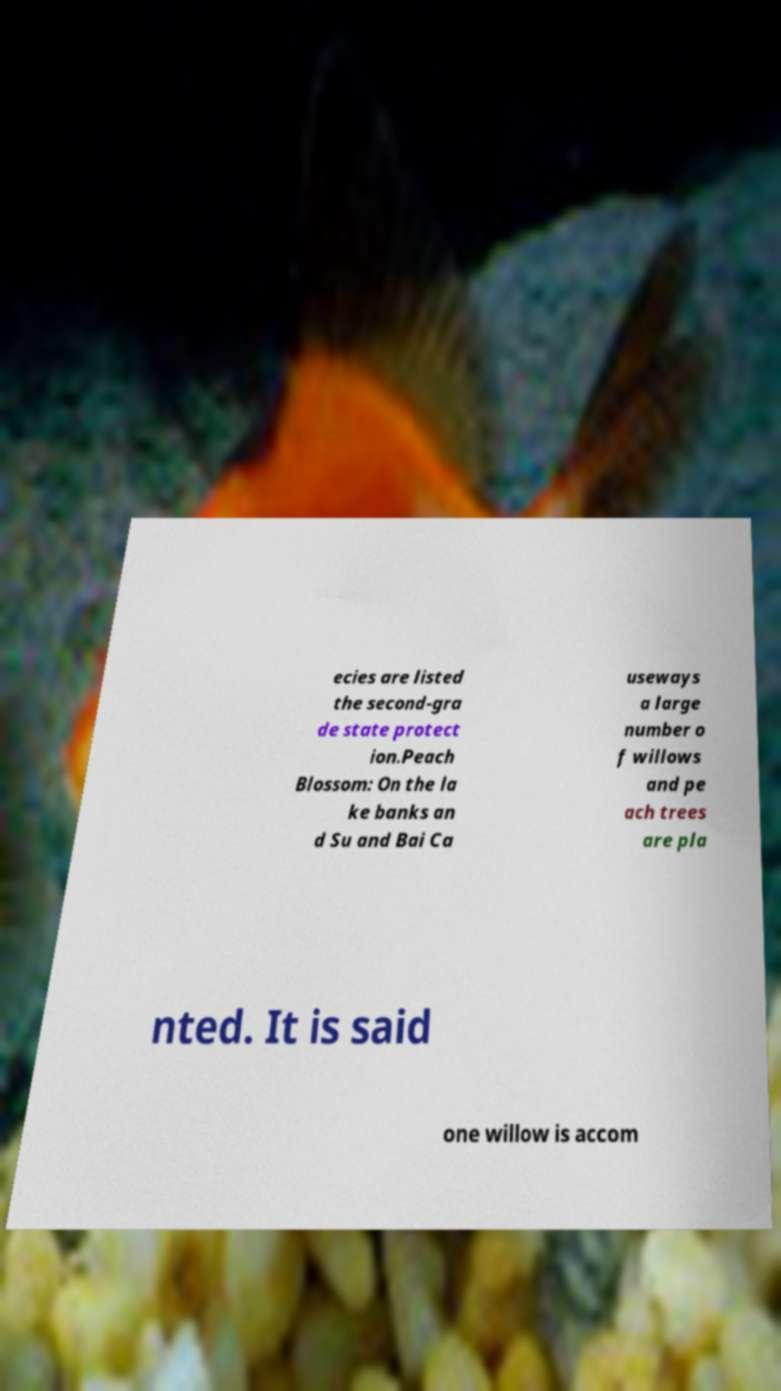What messages or text are displayed in this image? I need them in a readable, typed format. ecies are listed the second-gra de state protect ion.Peach Blossom: On the la ke banks an d Su and Bai Ca useways a large number o f willows and pe ach trees are pla nted. It is said one willow is accom 